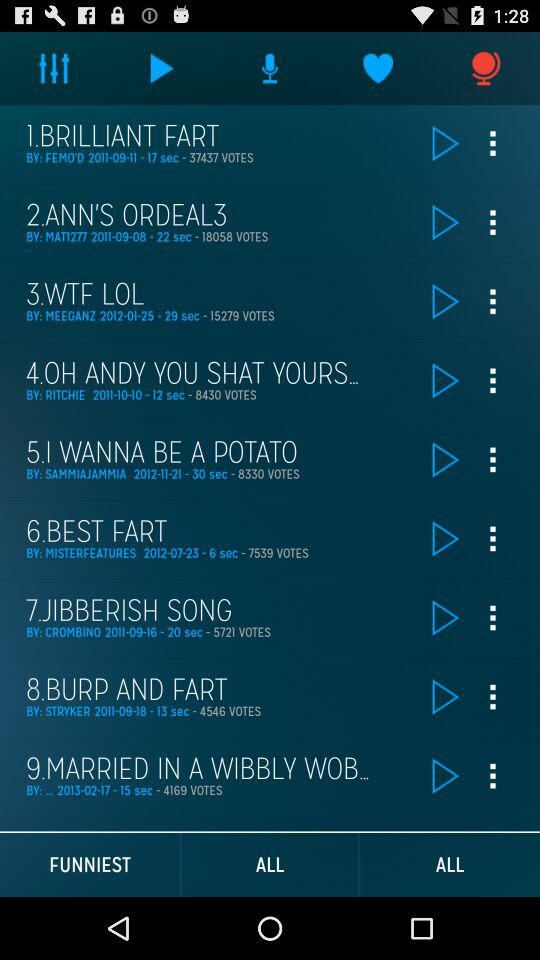What song did Ritchie sing? Ritchie sang the song " OH ANDY YOU SHAT YOURS...". 